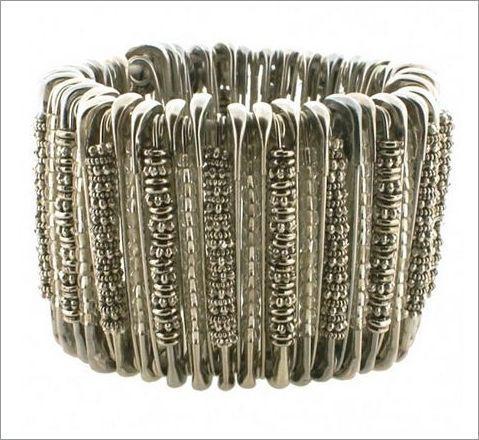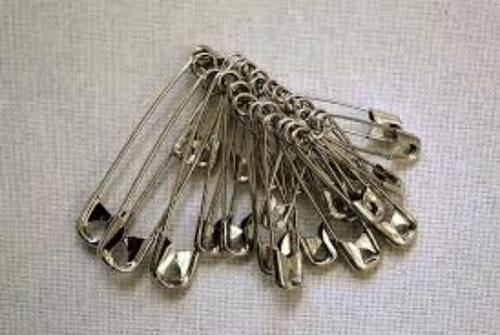The first image is the image on the left, the second image is the image on the right. For the images displayed, is the sentence "The jewelry in the right photo is not made with any silver colored safety pins." factually correct? Answer yes or no. No. The first image is the image on the left, the second image is the image on the right. Evaluate the accuracy of this statement regarding the images: "An image features a necklace strung with only gold safety pins.". Is it true? Answer yes or no. No. 